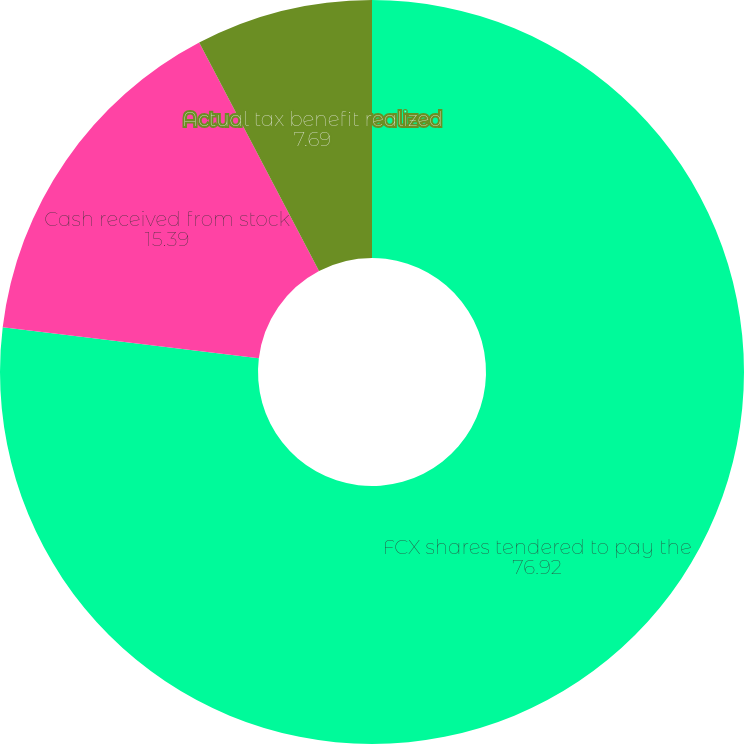<chart> <loc_0><loc_0><loc_500><loc_500><pie_chart><fcel>FCX shares tendered to pay the<fcel>Cash received from stock<fcel>Actual tax benefit realized<fcel>Amounts FCX paid for employee<nl><fcel>76.92%<fcel>15.39%<fcel>7.69%<fcel>0.0%<nl></chart> 